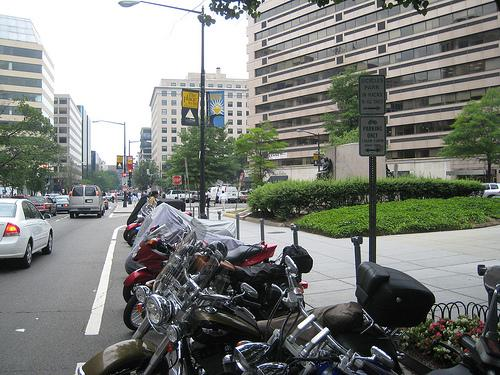Question: where was this picture taken?
Choices:
A. Road.
B. In a hotel.
C. Street.
D. In a hospital.
Answer with the letter. Answer: C Question: what kind of vehicles are parked along the right side of the road?
Choices:
A. Cars.
B. Trucks.
C. Scooter.
D. Motorcycles.
Answer with the letter. Answer: D Question: how many banners are attached to each light pole?
Choices:
A. One.
B. Zero.
C. Two.
D. Three.
Answer with the letter. Answer: C Question: what side of the street are people driving on?
Choices:
A. Right.
B. Left.
C. The wrong side.
D. Both.
Answer with the letter. Answer: A Question: what direction are the motorcycles pointed?
Choices:
A. Right.
B. Left.
C. North.
D. South.
Answer with the letter. Answer: B Question: what color is the closest car?
Choices:
A. White.
B. Black.
C. Gray.
D. Blue.
Answer with the letter. Answer: A 